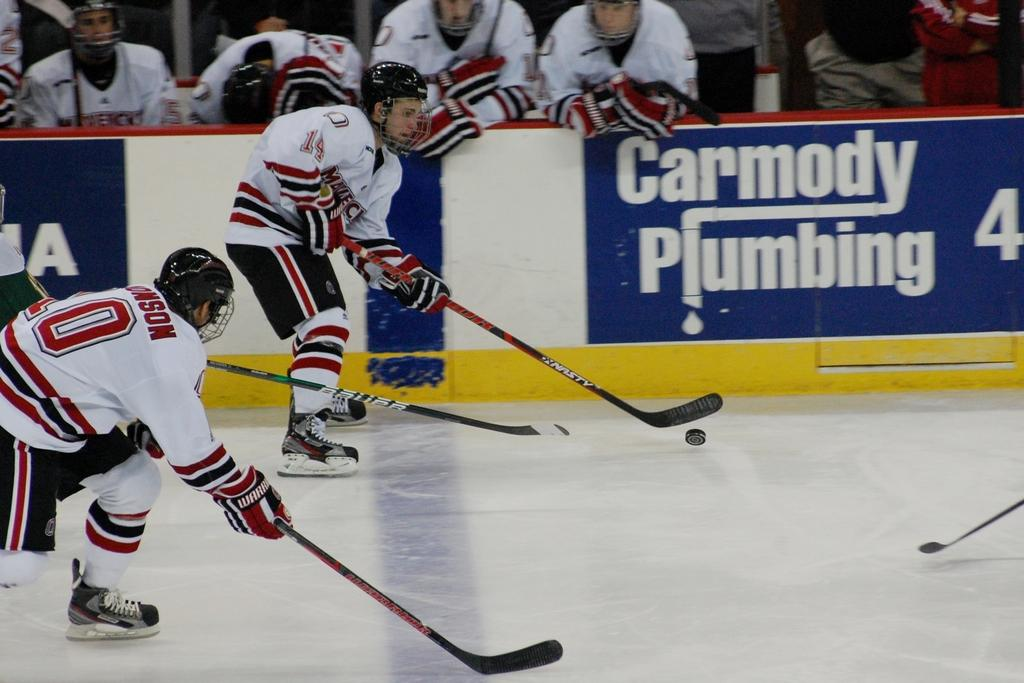How many people are present in the image? There are two persons in the image. What are the persons doing in the image? The persons are playing on the floor. What are the persons holding in their hands? The persons are holding sticks in their hands. What can be seen in the background of the image? There is a hoarding and people visible in the background of the image. What type of linen is being used by the ghost in the image? There is no ghost present in the image, and therefore no linen can be associated with it. 